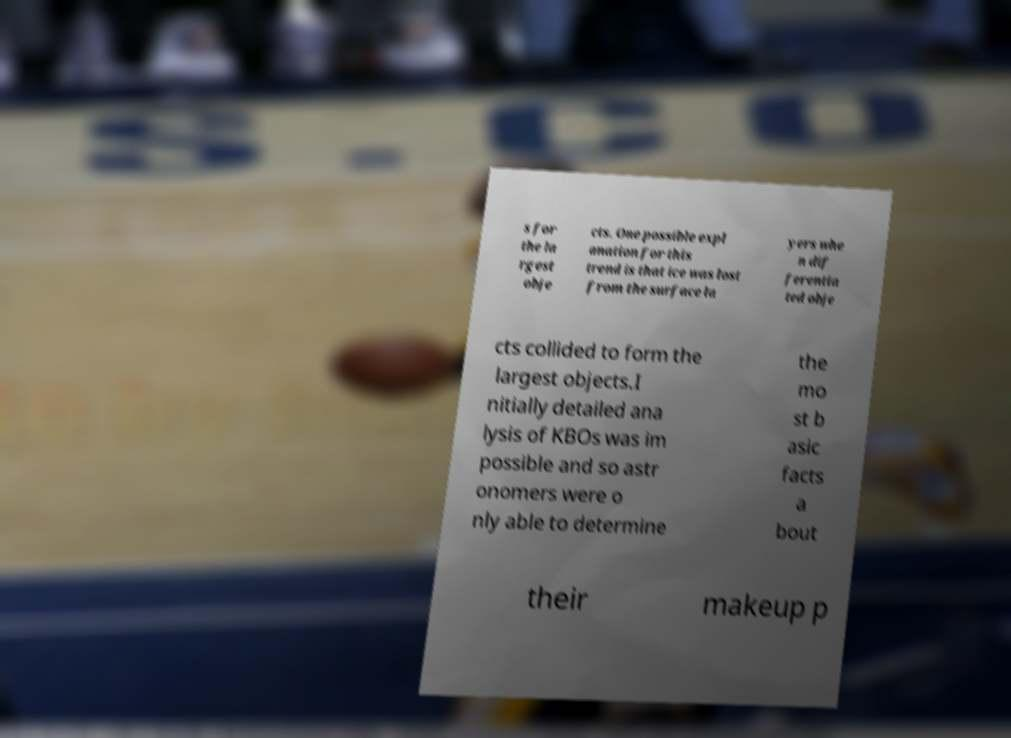For documentation purposes, I need the text within this image transcribed. Could you provide that? s for the la rgest obje cts. One possible expl anation for this trend is that ice was lost from the surface la yers whe n dif ferentia ted obje cts collided to form the largest objects.I nitially detailed ana lysis of KBOs was im possible and so astr onomers were o nly able to determine the mo st b asic facts a bout their makeup p 